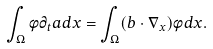<formula> <loc_0><loc_0><loc_500><loc_500>\int _ { \Omega } \phi \partial _ { t } a d x = \int _ { \Omega } ( b \cdot \nabla _ { x } ) \phi d x .</formula> 